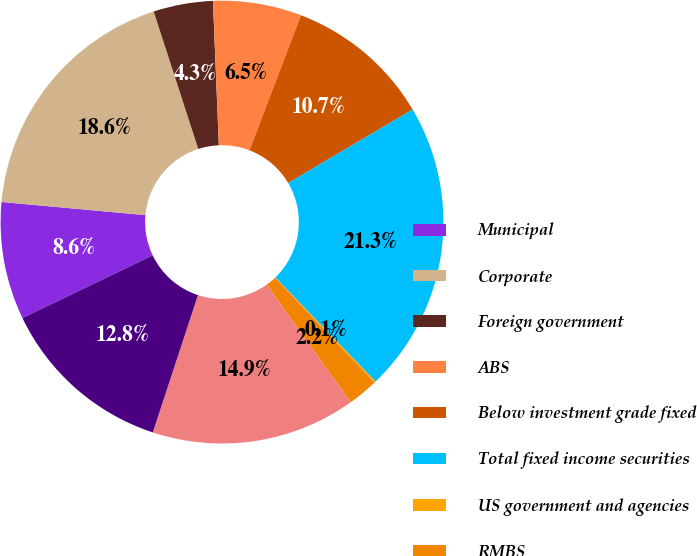Convert chart. <chart><loc_0><loc_0><loc_500><loc_500><pie_chart><fcel>Municipal<fcel>Corporate<fcel>Foreign government<fcel>ABS<fcel>Below investment grade fixed<fcel>Total fixed income securities<fcel>US government and agencies<fcel>RMBS<fcel>Total fixed income and equity<fcel>Investment grade fixed income<nl><fcel>8.58%<fcel>18.56%<fcel>4.34%<fcel>6.46%<fcel>10.7%<fcel>21.29%<fcel>0.11%<fcel>2.22%<fcel>14.93%<fcel>12.81%<nl></chart> 